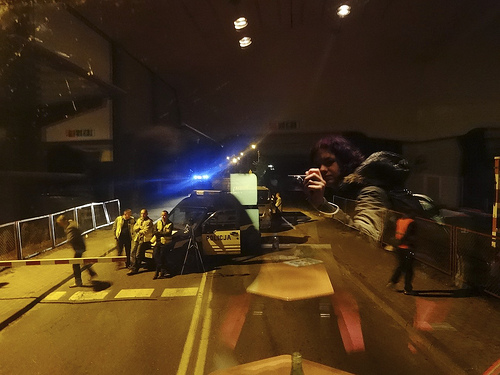<image>
Is there a car to the left of the person? Yes. From this viewpoint, the car is positioned to the left side relative to the person. 